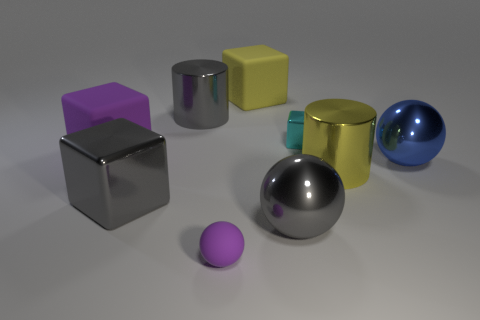What is the shape of the object that is the same color as the small rubber sphere?
Keep it short and to the point. Cube. How many cyan shiny blocks are the same size as the purple block?
Your response must be concise. 0. There is a large gray object to the right of the small matte object; are there any matte things in front of it?
Offer a terse response. Yes. What number of things are large red rubber balls or big metallic things?
Make the answer very short. 5. There is a metal cube to the left of the large gray object that is to the right of the big cylinder behind the yellow shiny object; what is its color?
Provide a succinct answer. Gray. Is there anything else that is the same color as the tiny matte thing?
Provide a succinct answer. Yes. Do the cyan metallic cube and the purple ball have the same size?
Give a very brief answer. Yes. What number of things are either yellow objects that are in front of the large blue metal thing or big gray things on the left side of the rubber ball?
Your answer should be very brief. 3. There is a cylinder that is right of the metallic thing that is behind the tiny cyan metal cube; what is its material?
Your response must be concise. Metal. How many other objects are there of the same material as the cyan cube?
Keep it short and to the point. 5. 